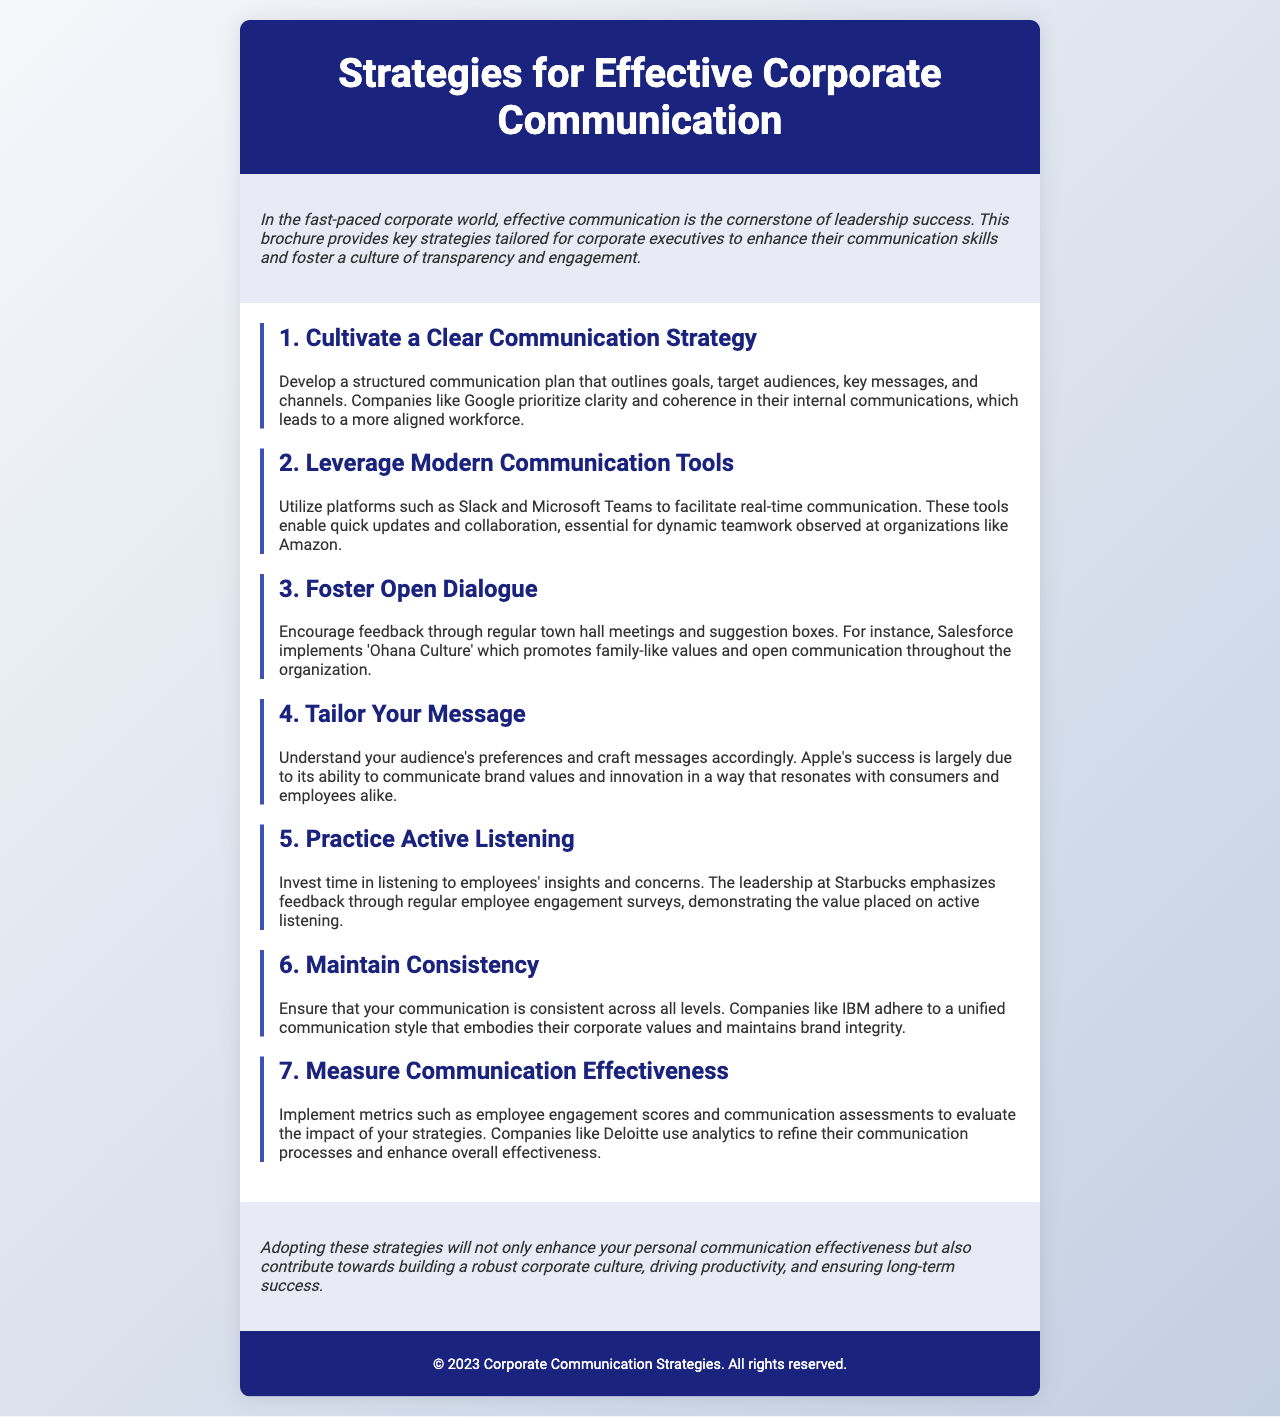What is the title of the brochure? The title is prominently displayed in the header section of the document, stating the focus on communication strategies.
Answer: Strategies for Effective Corporate Communication What company is mentioned as an example for having a clear communication strategy? The document cites a notable company that excels in structured communication plans, which leads to an aligned workforce.
Answer: Google Which tool is suggested for real-time communication? The brochure mentions specific platforms that facilitate quick updates and collaboration in modern workplaces.
Answer: Slack What organizational culture does Salesforce promote? The document highlights a specific culture that encourages open communication and family-like values in the organization.
Answer: Ohana Culture How many strategies are outlined in the brochure? The total number of strategies discussed in the content section provides an idea of the breadth of communication topics covered.
Answer: Seven What should be practiced according to the fifth strategy? This strategy emphasizes an essential skill necessary for effective communication in a corporate setting.
Answer: Active Listening Which company is mentioned in relation to measuring communication effectiveness? The document highlights a company that utilizes analytics to enhance communication processes.
Answer: Deloitte 